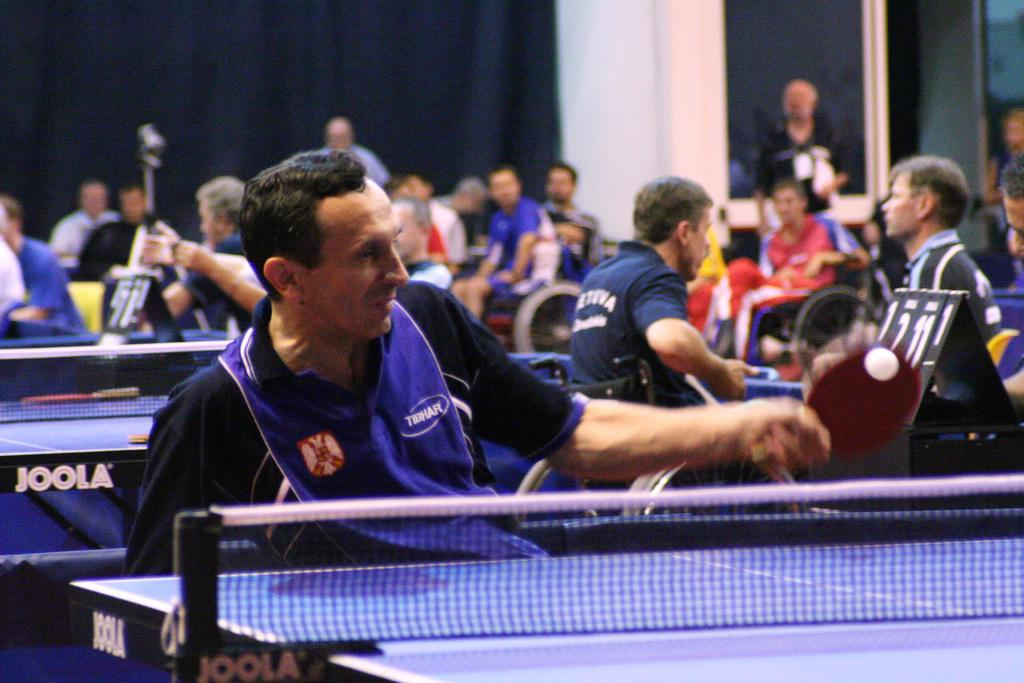What activity are the children engaged in at the playground? The children are playing in the playground. Where is the donkey nest located in the image? There is no donkey or nest present in the image. 